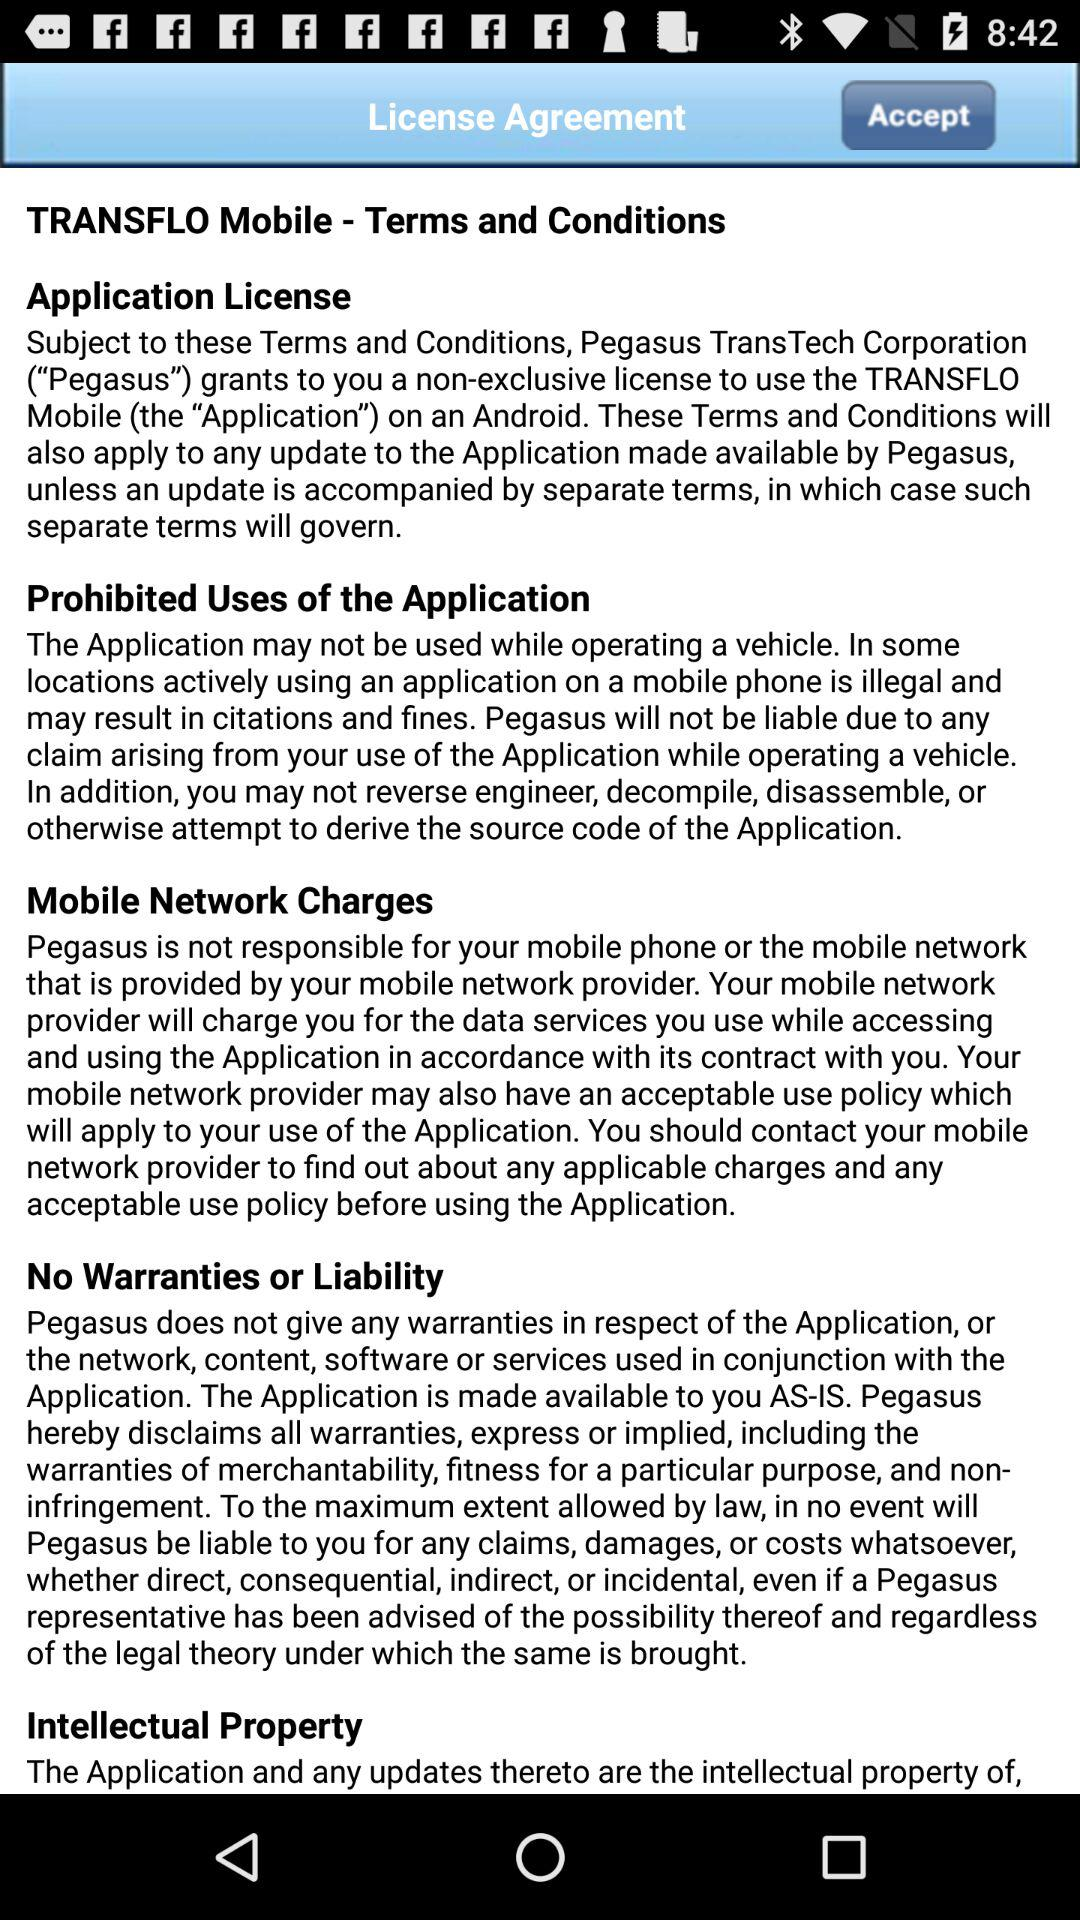What is a License agreement?
When the provided information is insufficient, respond with <no answer>. <no answer> 